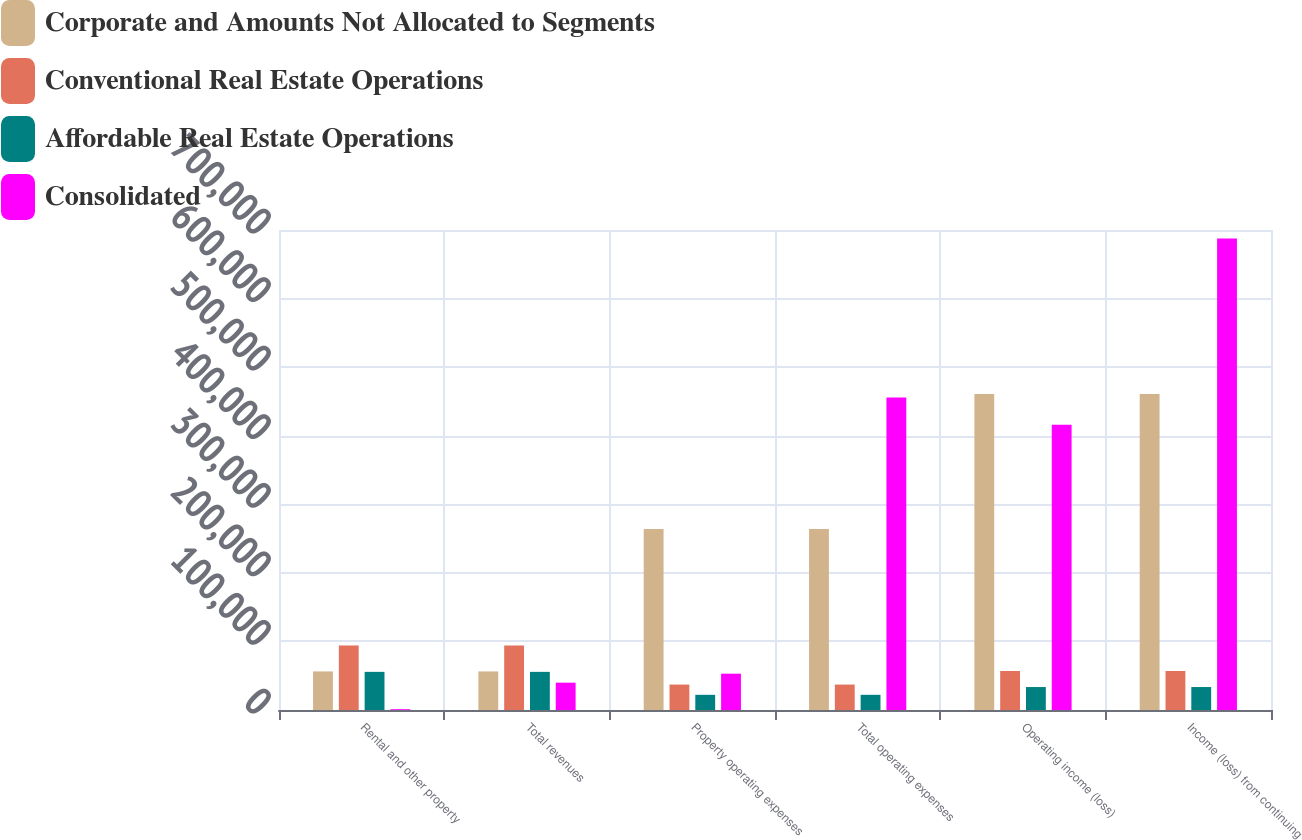Convert chart to OTSL. <chart><loc_0><loc_0><loc_500><loc_500><stacked_bar_chart><ecel><fcel>Rental and other property<fcel>Total revenues<fcel>Property operating expenses<fcel>Total operating expenses<fcel>Operating income (loss)<fcel>Income (loss) from continuing<nl><fcel>Corporate and Amounts Not Allocated to Segments<fcel>56269<fcel>56269<fcel>263969<fcel>263969<fcel>460897<fcel>460897<nl><fcel>Conventional Real Estate Operations<fcel>94007<fcel>94007<fcel>37096<fcel>37096<fcel>56911<fcel>56911<nl><fcel>Affordable Real Estate Operations<fcel>55627<fcel>55627<fcel>22140<fcel>22140<fcel>33487<fcel>33487<nl><fcel>Consolidated<fcel>1194<fcel>39855<fcel>52959<fcel>455859<fcel>416004<fcel>687532<nl></chart> 